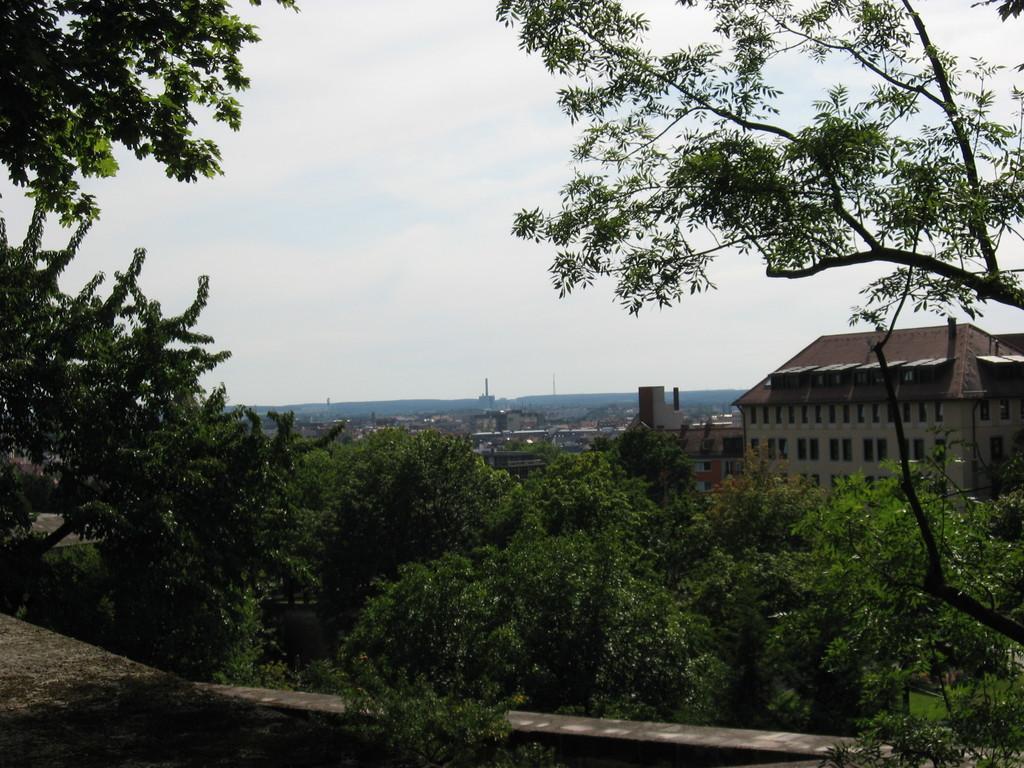How would you summarize this image in a sentence or two? In this image we can see trees and buildings. There is a wall at the bottom of the image and the sky at the top of the image. 